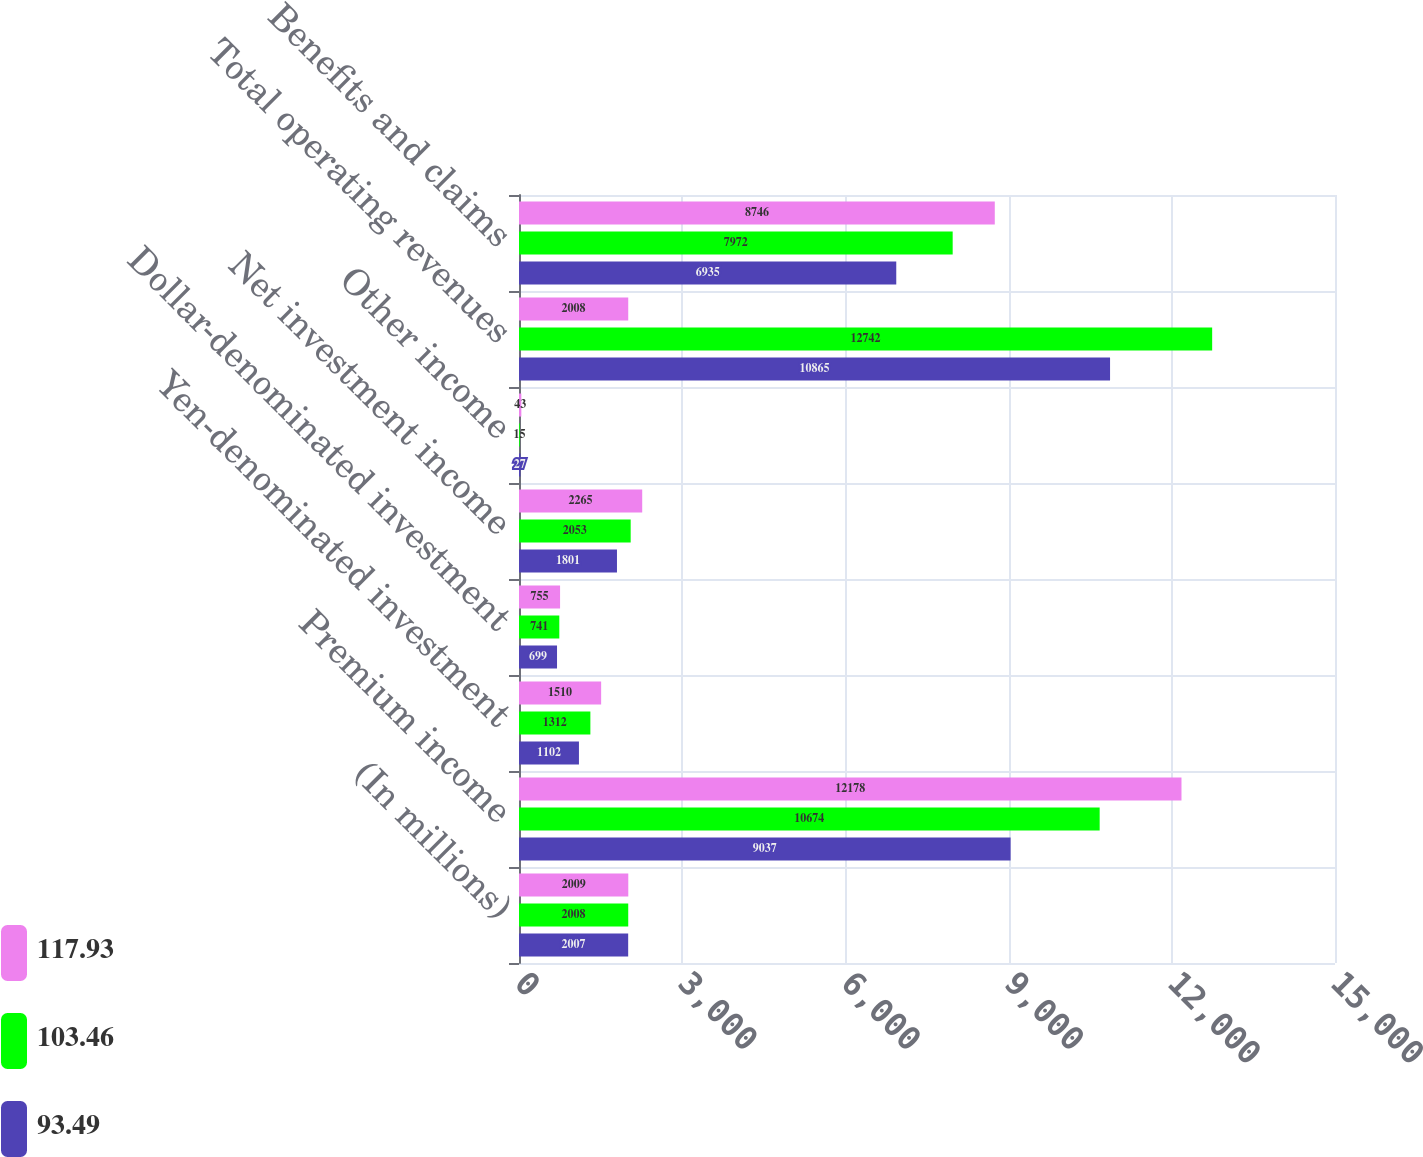Convert chart. <chart><loc_0><loc_0><loc_500><loc_500><stacked_bar_chart><ecel><fcel>(In millions)<fcel>Premium income<fcel>Yen-denominated investment<fcel>Dollar-denominated investment<fcel>Net investment income<fcel>Other income<fcel>Total operating revenues<fcel>Benefits and claims<nl><fcel>117.93<fcel>2009<fcel>12178<fcel>1510<fcel>755<fcel>2265<fcel>43<fcel>2008<fcel>8746<nl><fcel>103.46<fcel>2008<fcel>10674<fcel>1312<fcel>741<fcel>2053<fcel>15<fcel>12742<fcel>7972<nl><fcel>93.49<fcel>2007<fcel>9037<fcel>1102<fcel>699<fcel>1801<fcel>27<fcel>10865<fcel>6935<nl></chart> 